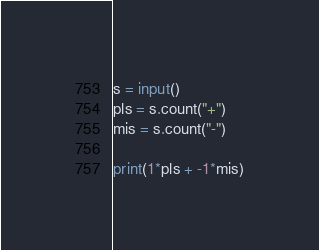Convert code to text. <code><loc_0><loc_0><loc_500><loc_500><_Python_>s = input()
pls = s.count("+")
mis = s.count("-")

print(1*pls + -1*mis)</code> 